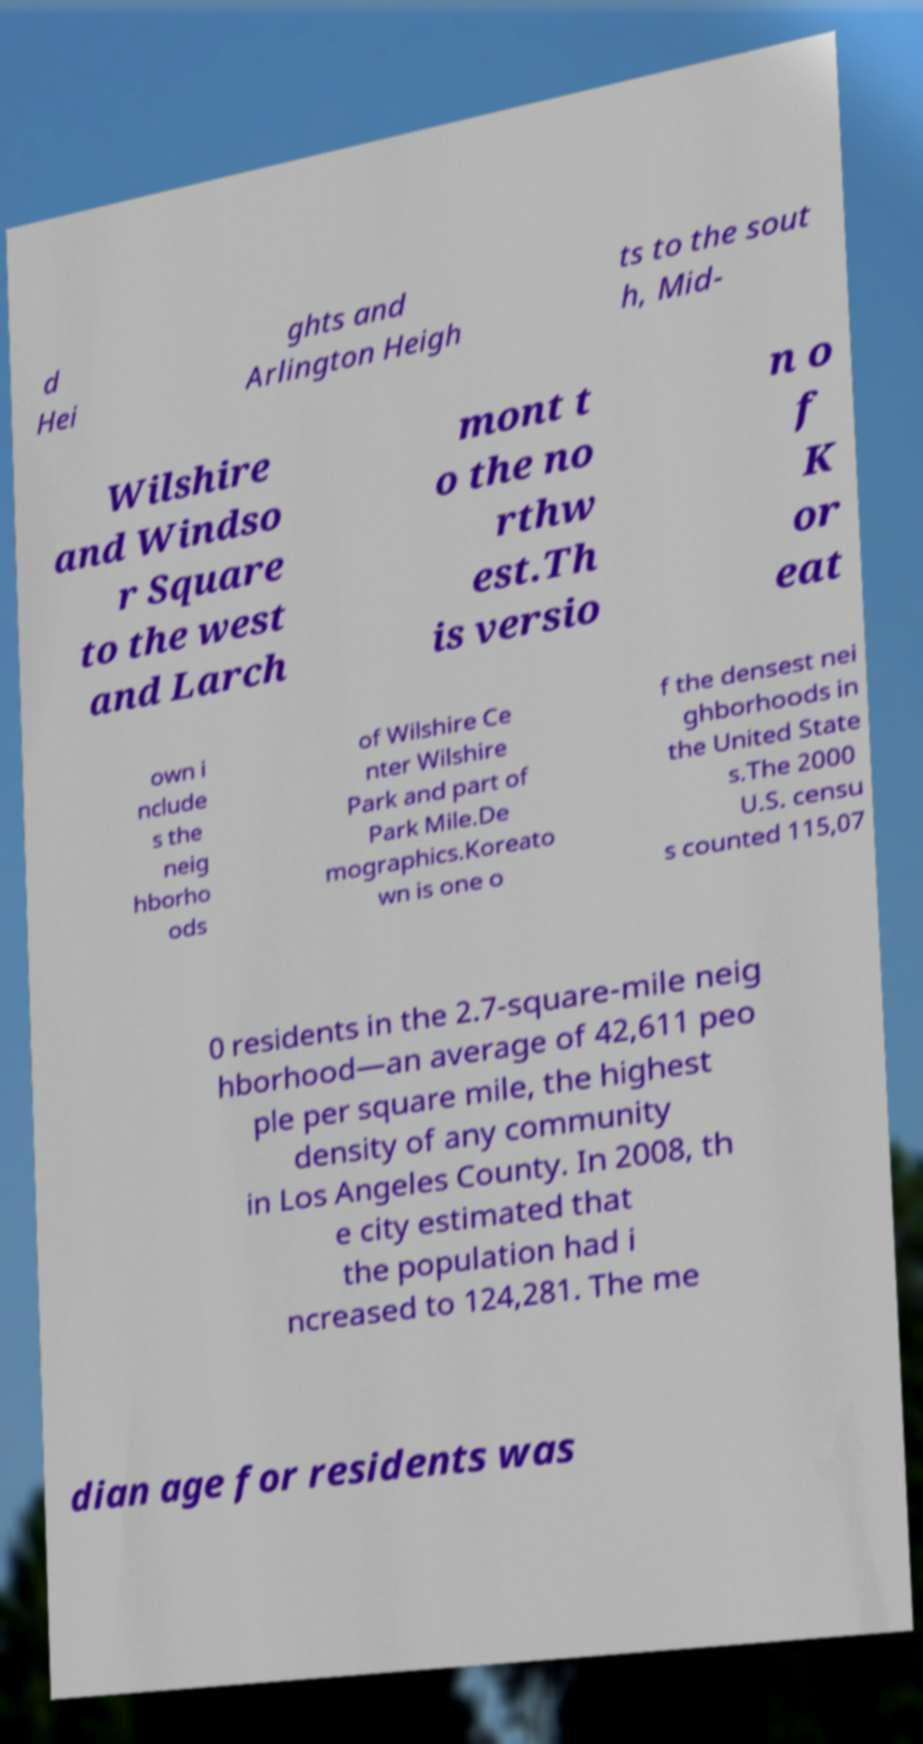Can you read and provide the text displayed in the image?This photo seems to have some interesting text. Can you extract and type it out for me? d Hei ghts and Arlington Heigh ts to the sout h, Mid- Wilshire and Windso r Square to the west and Larch mont t o the no rthw est.Th is versio n o f K or eat own i nclude s the neig hborho ods of Wilshire Ce nter Wilshire Park and part of Park Mile.De mographics.Koreato wn is one o f the densest nei ghborhoods in the United State s.The 2000 U.S. censu s counted 115,07 0 residents in the 2.7-square-mile neig hborhood—an average of 42,611 peo ple per square mile, the highest density of any community in Los Angeles County. In 2008, th e city estimated that the population had i ncreased to 124,281. The me dian age for residents was 